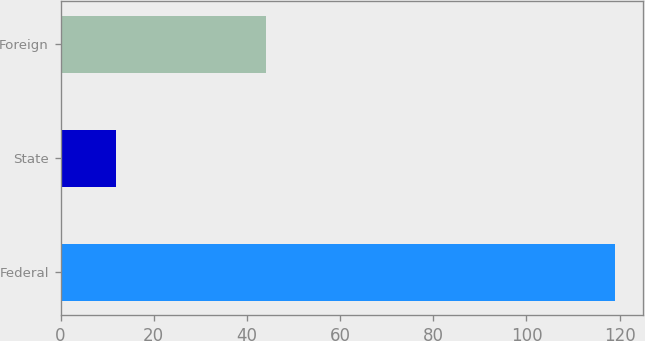<chart> <loc_0><loc_0><loc_500><loc_500><bar_chart><fcel>Federal<fcel>State<fcel>Foreign<nl><fcel>119<fcel>12<fcel>44<nl></chart> 